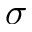Convert formula to latex. <formula><loc_0><loc_0><loc_500><loc_500>\sigma</formula> 